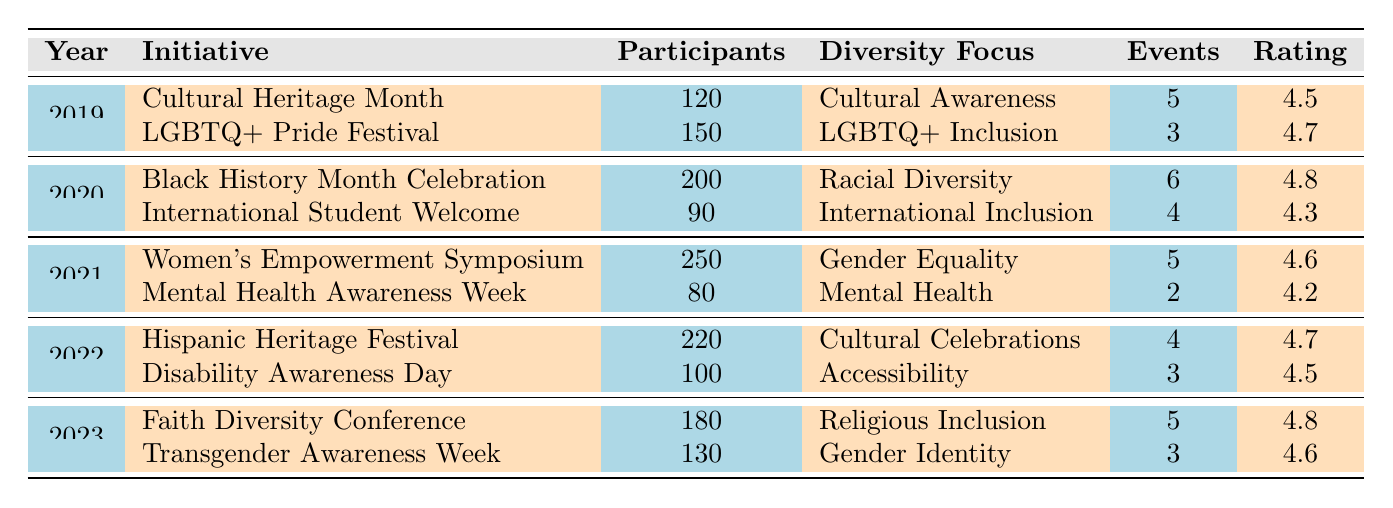What was the participation rate at the Women's Empowerment Symposium in 2021? The table shows that the Women's Empowerment Symposium in 2021 had 250 participants, which directly answers the question.
Answer: 250 Which initiative in 2022 had the highest feedback rating? By looking at the ratings in the table for 2022, the Hispanic Heritage Festival had a rating of 4.7, which is higher than the 4.5 rating for Disability Awareness Day.
Answer: Hispanic Heritage Festival What is the total number of events held across all initiatives in 2019? The table shows that in 2019, there were 5 events for Cultural Heritage Month and 3 events for the LGBTQ+ Pride Festival. Adding these gives 5 + 3 = 8 total events for that year.
Answer: 8 Did the initiatives in 2020 have more participants than those in 2021? In 2020, the initiatives had a total of 290 participants (200 from Black History Month Celebration and 90 from International Student Welcome), while in 2021 the total was 330 participants (250 from Women's Empowerment Symposium and 80 from Mental Health Awareness Week). Since 290 is less than 330, the answer is no.
Answer: No What is the average number of participants across all initiatives in 2022? In 2022, there were two initiatives: Hispanic Heritage Festival with 220 participants and Disability Awareness Day with 100 participants. The sum of participants is 220 + 100 = 320. There are 2 initiatives, so the average is 320 / 2 = 160.
Answer: 160 Which diversity focus had the highest participation in the data set? By reviewing the participants, the highest number is 250 from the Women's Empowerment Symposium under the Gender Equality focus, which is greater than all other initiatives.
Answer: Gender Equality What percentage of total participants in 2019 were part of the LGBTQ+ Pride Festival? In 2019, there were a total of 270 participants (120 for Cultural Heritage Month and 150 for LGBTQ+ Pride Festival). The LGBTQ+ Pride Festival had 150 participants, which is (150 / 270) * 100 = 55.56%.
Answer: 55.56% Was there a year when all initiatives had a feedback rating above 4.5? In the table, 2021 had a Women's Empowerment Symposium with a rating of 4.6 and Mental Health Awareness Week with a rating of 4.2. Since 4.2 is below 4.5, the answer is no for that year. Checking 2022 reveals the same issue, with a rating of 4.5 for one initiative. Therefore, no year had all initiatives above 4.5.
Answer: No 